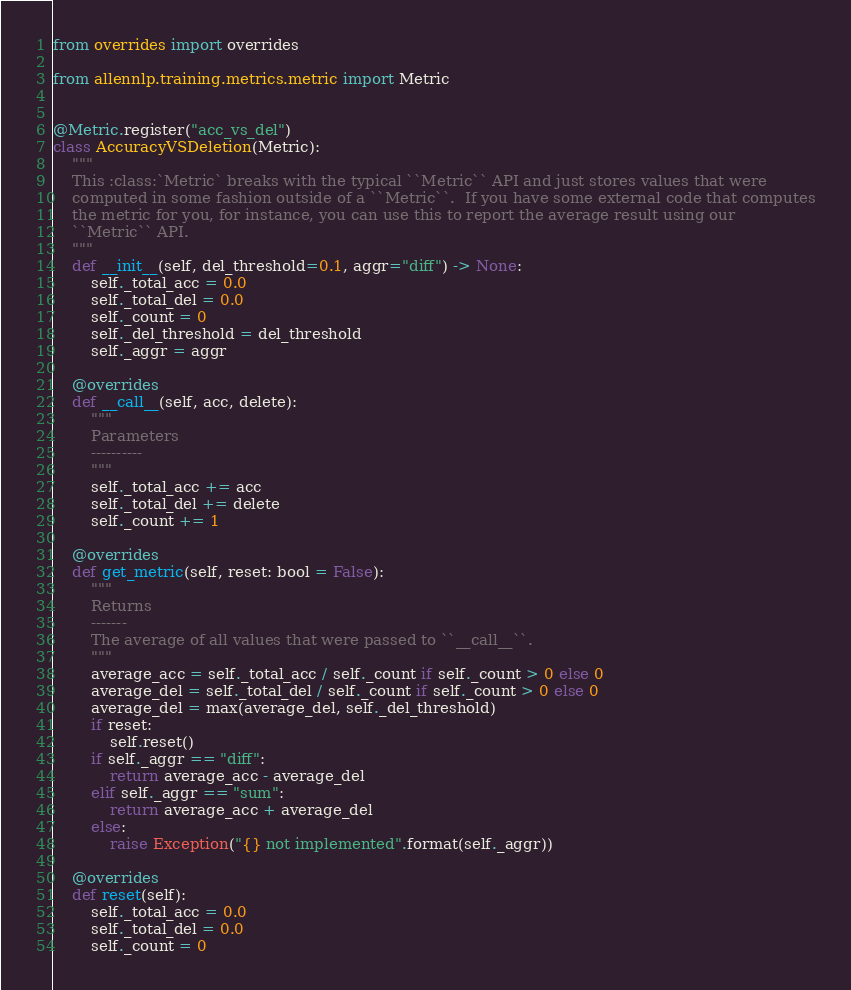Convert code to text. <code><loc_0><loc_0><loc_500><loc_500><_Python_>from overrides import overrides

from allennlp.training.metrics.metric import Metric


@Metric.register("acc_vs_del")
class AccuracyVSDeletion(Metric):
    """
    This :class:`Metric` breaks with the typical ``Metric`` API and just stores values that were
    computed in some fashion outside of a ``Metric``.  If you have some external code that computes
    the metric for you, for instance, you can use this to report the average result using our
    ``Metric`` API.
    """
    def __init__(self, del_threshold=0.1, aggr="diff") -> None:
        self._total_acc = 0.0
        self._total_del = 0.0
        self._count = 0
        self._del_threshold = del_threshold
        self._aggr = aggr

    @overrides
    def __call__(self, acc, delete):
        """
        Parameters
        ----------
        """
        self._total_acc += acc
        self._total_del += delete
        self._count += 1

    @overrides
    def get_metric(self, reset: bool = False):
        """
        Returns
        -------
        The average of all values that were passed to ``__call__``.
        """
        average_acc = self._total_acc / self._count if self._count > 0 else 0
        average_del = self._total_del / self._count if self._count > 0 else 0
        average_del = max(average_del, self._del_threshold)
        if reset:
            self.reset()
        if self._aggr == "diff":
            return average_acc - average_del
        elif self._aggr == "sum":
            return average_acc + average_del
        else:
            raise Exception("{} not implemented".format(self._aggr))

    @overrides
    def reset(self):
        self._total_acc = 0.0
        self._total_del = 0.0
        self._count = 0
</code> 